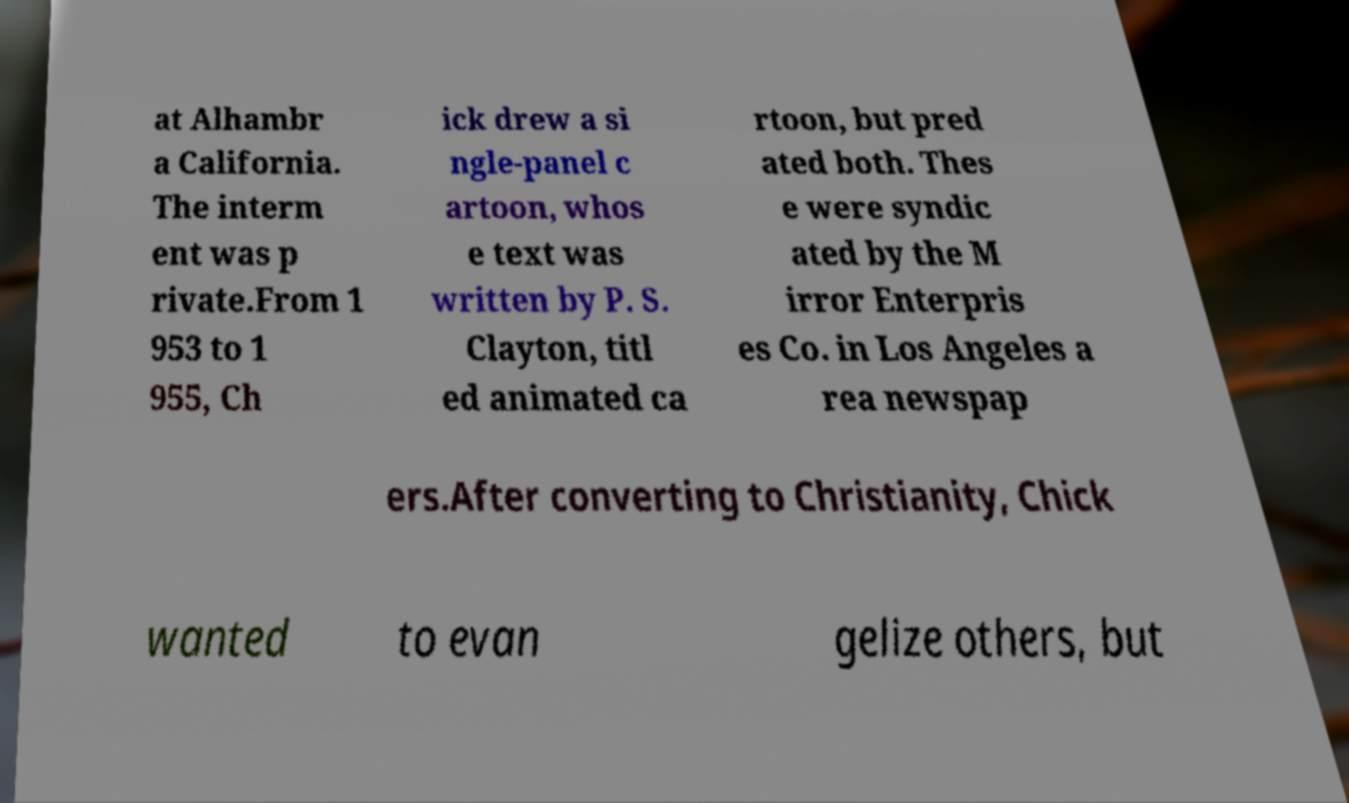Please identify and transcribe the text found in this image. at Alhambr a California. The interm ent was p rivate.From 1 953 to 1 955, Ch ick drew a si ngle-panel c artoon, whos e text was written by P. S. Clayton, titl ed animated ca rtoon, but pred ated both. Thes e were syndic ated by the M irror Enterpris es Co. in Los Angeles a rea newspap ers.After converting to Christianity, Chick wanted to evan gelize others, but 